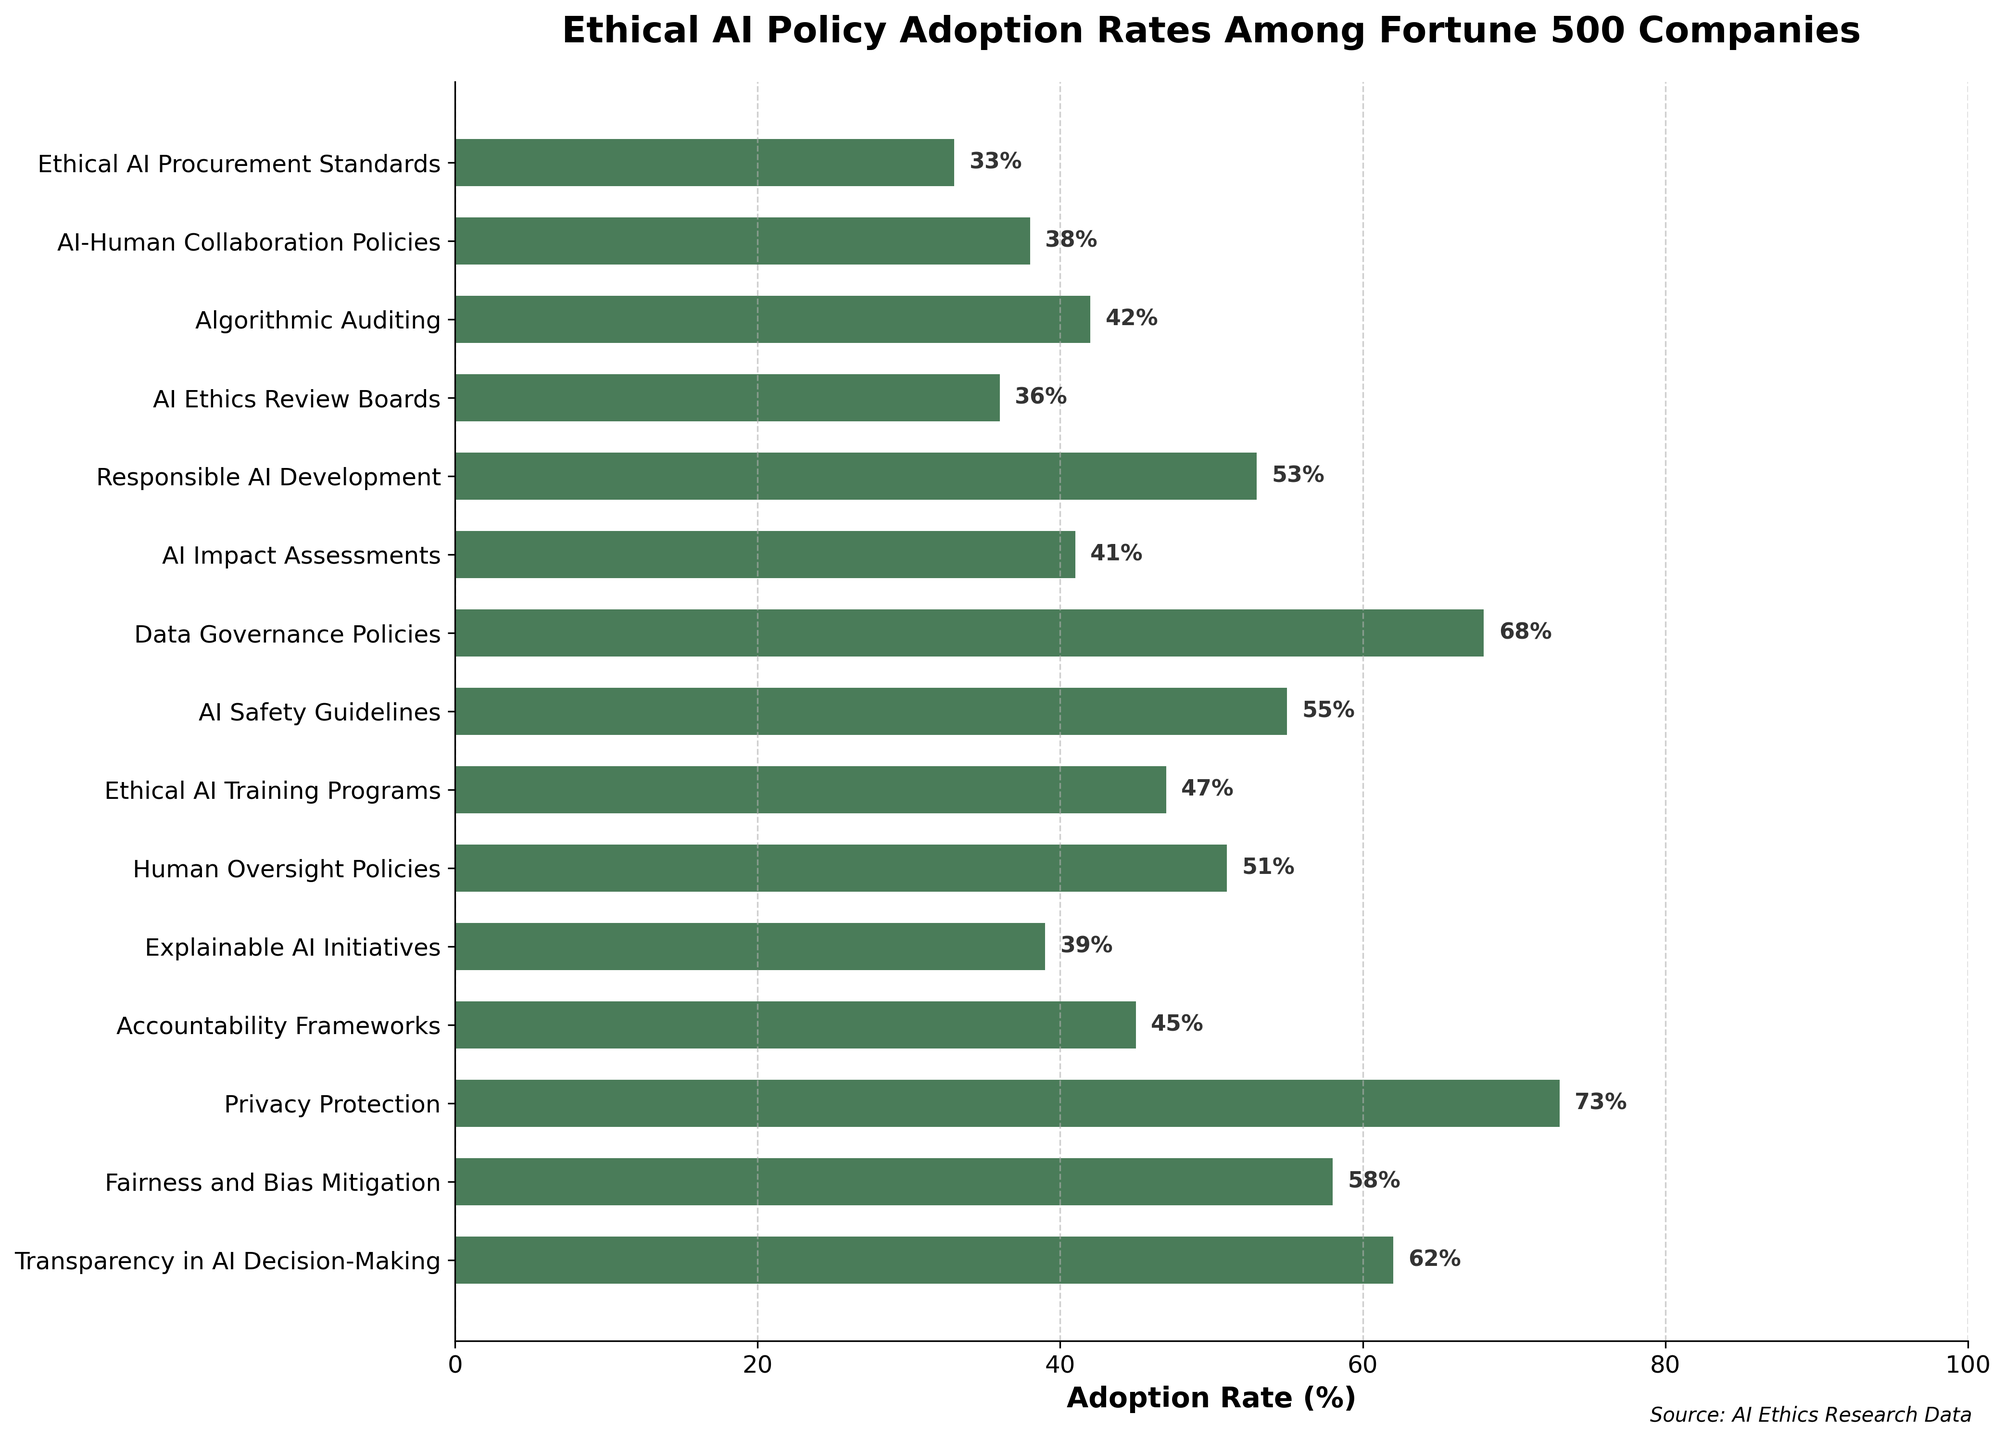Which ethical AI policy has the highest adoption rate? The policy with the highest adoption rate is the one with the tallest bar in the bar chart. By looking at the heights of the bars, the tallest bar corresponds to "Privacy Protection" with an adoption rate of 73%.
Answer: Privacy Protection What is the difference in adoption rate between "Transparency in AI Decision-Making" and "Accountability Frameworks"? First, find the adoption rates of both policies: "Transparency in AI Decision-Making" is 62%, and "Accountability Frameworks" is 45%. The difference is calculated as 62% - 45% = 17%.
Answer: 17% Which policy has a lower adoption rate, "AI Safety Guidelines" or "Explainable AI Initiatives"? Compare the heights of the bars corresponding to each policy. "AI Safety Guidelines" has an adoption rate of 55%, while "Explainable AI Initiatives" has an adoption rate of 39%. Since 39% is less than 55%, "Explainable AI Initiatives" has a lower adoption rate.
Answer: Explainable AI Initiatives What is the sum of the adoption rates for "Human Oversight Policies" and "Ethical AI Training Programs"? First, find the adoption rates: "Human Oversight Policies" is 51%, and "Ethical AI Training Programs" is 47%. Summing them up, 51 + 47 = 98.
Answer: 98% How do the adoption rates of the top three policies compare to each other? The top three policies by adoption rate are "Privacy Protection" (73%), "Data Governance Policies" (68%), and "Transparency in AI Decision-Making" (62%). From highest to lowest, the rates are 73%, 68%, and 62%.
Answer: 73%, 68%, 62% Are there more policies with an adoption rate below 50% or above 50%? Count the number of policies above and below 50%. Below 50%: "Accountability Frameworks" (45%), "Explainable AI Initiatives" (39%), "AI Impact Assessments" (41%), "AI Ethics Review Boards" (36%), "Algorithmic Auditing" (42%), "AI-Human Collaboration Policies" (38%), "Ethical AI Procurement Standards" (33%)—7 policies. Above 50%: "Transparency in AI Decision-Making" (62%), "Fairness and Bias Mitigation" (58%), "Privacy Protection" (73%), "Human Oversight Policies" (51%), "AI Safety Guidelines" (55%), "Data Governance Policies" (68%), "Responsible AI Development" (53%)—7 policies. They are equal.
Answer: Equal Which policy has the smallest adoption rate, and what is its rate? The policy with the smallest adoption rate is the one with the shortest bar in the bar chart. "Ethical AI Procurement Standards" has the shortest bar with an adoption rate of 33%.
Answer: Ethical AI Procurement Standards, 33% What is the average adoption rate of all the policies listed? Add up all the adoption rates and divide by the number of policies. Sum = 62 + 58 + 73 + 45 + 39 + 51 + 47 + 55 + 68 + 41 + 53 + 36 + 42 + 38 + 33 = 741. Number of policies = 15. Average = 741 / 15 = 49.4.
Answer: 49.4 Which policies have adoption rates within the range of 40-50%? Locate the bars with heights corresponding to the 40-50% range: "Accountability Frameworks" (45%), "AI Impact Assessments" (41%), "Algorithmic Auditing" (42%), "AI-Human Collaboration Policies" (38%—not within the range). The policies are "Accountability Frameworks," "AI Impact Assessments," and "Algorithmic Auditing."
Answer: Accountability Frameworks, AI Impact Assessments, Algorithmic Auditing 